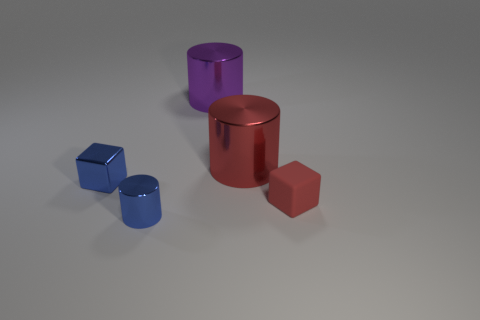What number of blocks are the same size as the blue metal cylinder?
Your response must be concise. 2. Is the red thing that is behind the tiny rubber cube made of the same material as the tiny cube that is left of the tiny blue cylinder?
Make the answer very short. Yes. What is the material of the small block left of the block to the right of the metal block?
Make the answer very short. Metal. What is the large cylinder in front of the big purple metallic object made of?
Keep it short and to the point. Metal. How many purple things are the same shape as the large red shiny object?
Give a very brief answer. 1. Do the tiny rubber cube and the small metallic cylinder have the same color?
Your answer should be very brief. No. What is the material of the tiny cube right of the small cube that is to the left of the red thing that is behind the shiny cube?
Your answer should be compact. Rubber. Are there any tiny matte objects behind the large red shiny object?
Give a very brief answer. No. What is the shape of the purple thing that is the same size as the red shiny object?
Give a very brief answer. Cylinder. Is the material of the red cylinder the same as the tiny blue cylinder?
Provide a succinct answer. Yes. 